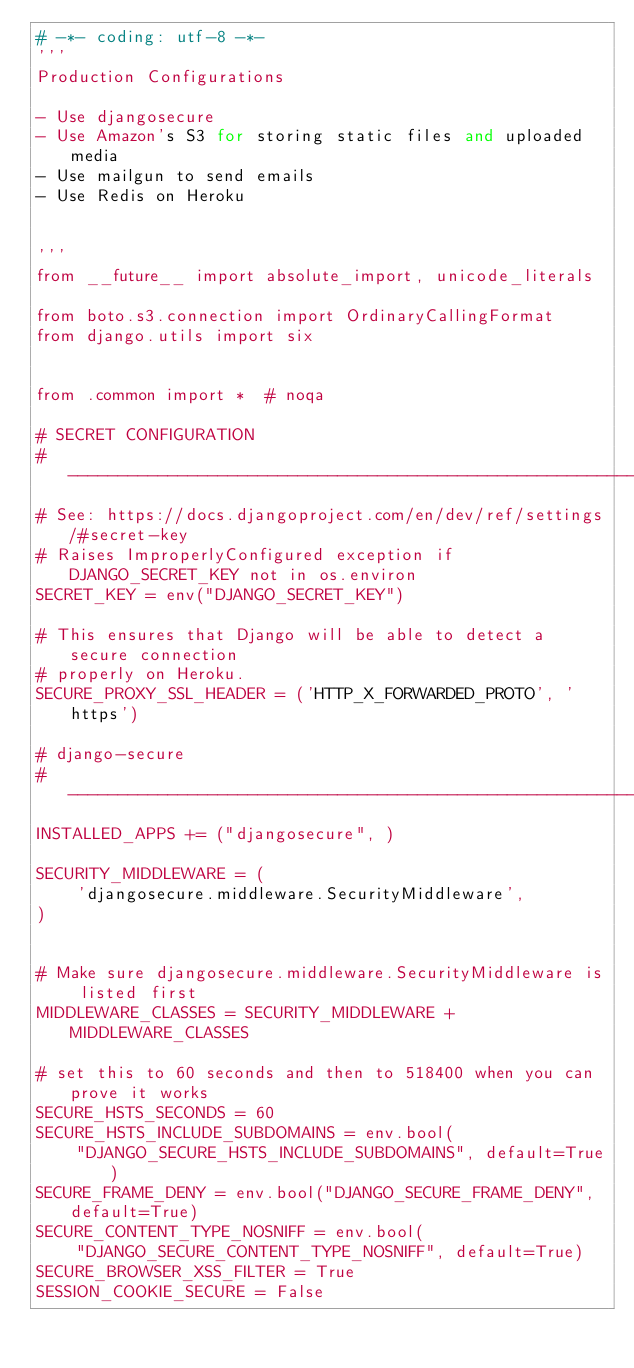<code> <loc_0><loc_0><loc_500><loc_500><_Python_># -*- coding: utf-8 -*-
'''
Production Configurations

- Use djangosecure
- Use Amazon's S3 for storing static files and uploaded media
- Use mailgun to send emails
- Use Redis on Heroku


'''
from __future__ import absolute_import, unicode_literals

from boto.s3.connection import OrdinaryCallingFormat
from django.utils import six


from .common import *  # noqa

# SECRET CONFIGURATION
# ------------------------------------------------------------------------------
# See: https://docs.djangoproject.com/en/dev/ref/settings/#secret-key
# Raises ImproperlyConfigured exception if DJANGO_SECRET_KEY not in os.environ
SECRET_KEY = env("DJANGO_SECRET_KEY")

# This ensures that Django will be able to detect a secure connection
# properly on Heroku.
SECURE_PROXY_SSL_HEADER = ('HTTP_X_FORWARDED_PROTO', 'https')

# django-secure
# ------------------------------------------------------------------------------
INSTALLED_APPS += ("djangosecure", )

SECURITY_MIDDLEWARE = (
    'djangosecure.middleware.SecurityMiddleware',
)


# Make sure djangosecure.middleware.SecurityMiddleware is listed first
MIDDLEWARE_CLASSES = SECURITY_MIDDLEWARE + MIDDLEWARE_CLASSES

# set this to 60 seconds and then to 518400 when you can prove it works
SECURE_HSTS_SECONDS = 60
SECURE_HSTS_INCLUDE_SUBDOMAINS = env.bool(
    "DJANGO_SECURE_HSTS_INCLUDE_SUBDOMAINS", default=True)
SECURE_FRAME_DENY = env.bool("DJANGO_SECURE_FRAME_DENY", default=True)
SECURE_CONTENT_TYPE_NOSNIFF = env.bool(
    "DJANGO_SECURE_CONTENT_TYPE_NOSNIFF", default=True)
SECURE_BROWSER_XSS_FILTER = True
SESSION_COOKIE_SECURE = False</code> 